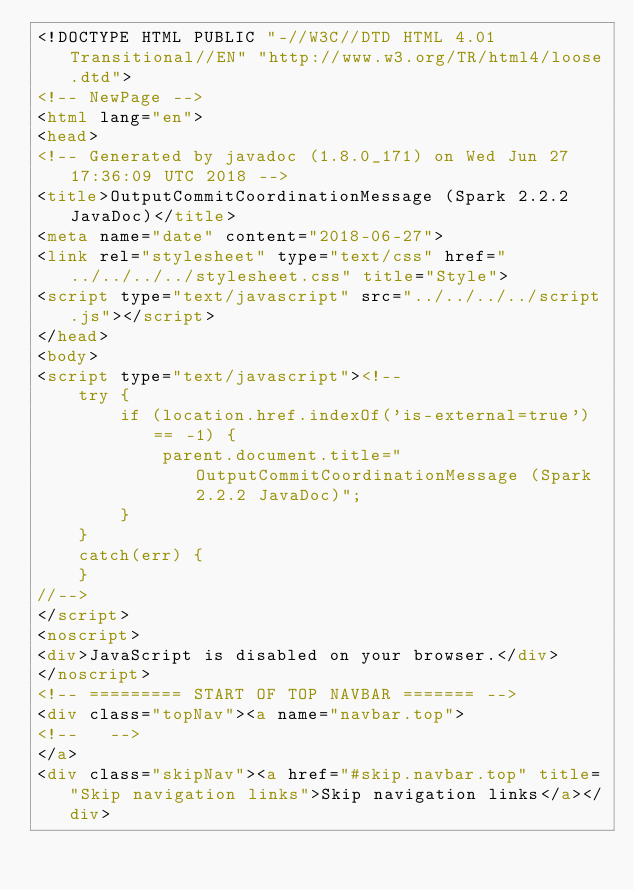Convert code to text. <code><loc_0><loc_0><loc_500><loc_500><_HTML_><!DOCTYPE HTML PUBLIC "-//W3C//DTD HTML 4.01 Transitional//EN" "http://www.w3.org/TR/html4/loose.dtd">
<!-- NewPage -->
<html lang="en">
<head>
<!-- Generated by javadoc (1.8.0_171) on Wed Jun 27 17:36:09 UTC 2018 -->
<title>OutputCommitCoordinationMessage (Spark 2.2.2 JavaDoc)</title>
<meta name="date" content="2018-06-27">
<link rel="stylesheet" type="text/css" href="../../../../stylesheet.css" title="Style">
<script type="text/javascript" src="../../../../script.js"></script>
</head>
<body>
<script type="text/javascript"><!--
    try {
        if (location.href.indexOf('is-external=true') == -1) {
            parent.document.title="OutputCommitCoordinationMessage (Spark 2.2.2 JavaDoc)";
        }
    }
    catch(err) {
    }
//-->
</script>
<noscript>
<div>JavaScript is disabled on your browser.</div>
</noscript>
<!-- ========= START OF TOP NAVBAR ======= -->
<div class="topNav"><a name="navbar.top">
<!--   -->
</a>
<div class="skipNav"><a href="#skip.navbar.top" title="Skip navigation links">Skip navigation links</a></div></code> 